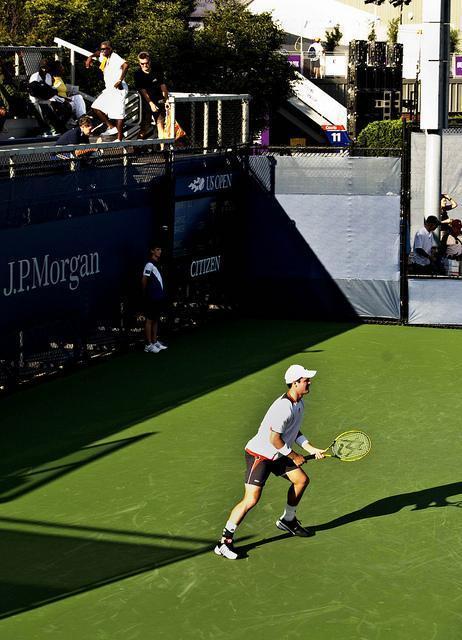How many people are there?
Give a very brief answer. 2. How many rows of benches are there?
Give a very brief answer. 0. 